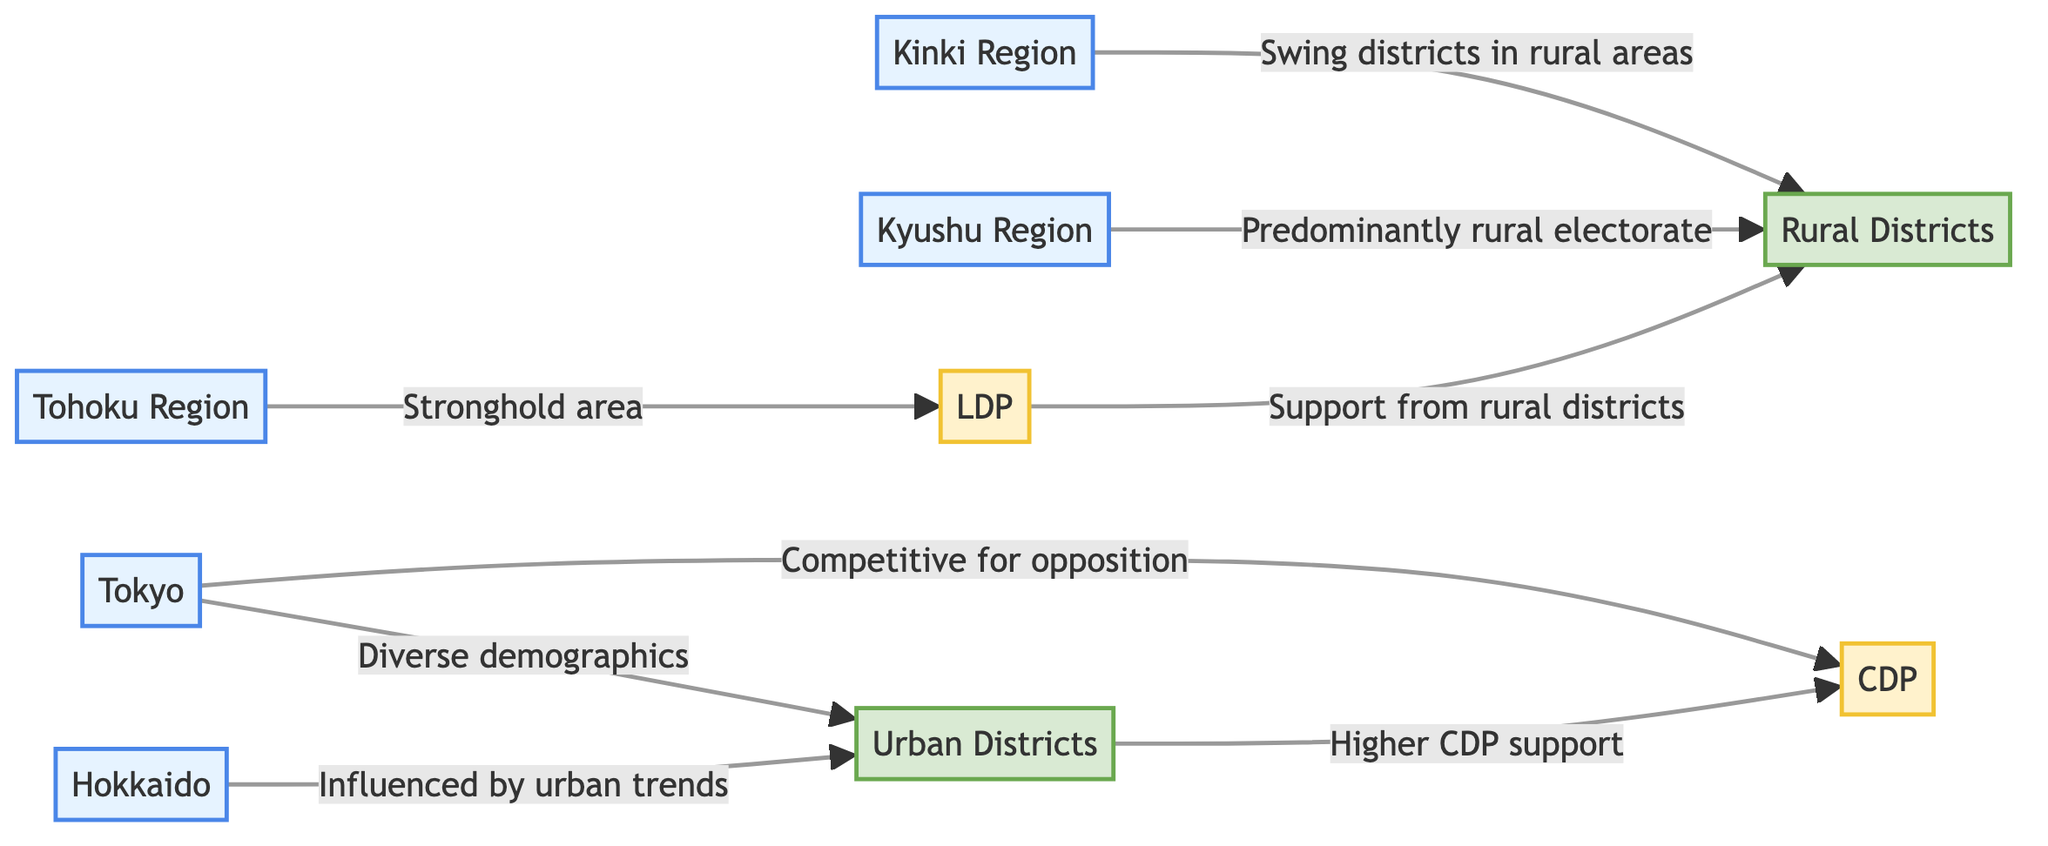What region in Japan is influenced by urban trends? The diagram connects Hokkaido to Urban Districts with the label "Influenced by urban trends," indicating that Hokkaido is affected by urban trends.
Answer: Hokkaido Which region shows a stronghold area for the LDP? The diagram connects the Tohoku Region with LDP, marked as a "Stronghold area," confirming that this region is known for its support for the Liberal Democratic Party.
Answer: Tohoku Region How many primary regions are illustrated in the diagram? By counting the regions shown in the diagram, we find five separate regions: Hokkaido, Tohoku Region, Tokyo, Kinki Region, and Kyushu Region.
Answer: 5 What party predominantly receives support from rural districts? The diagram shows a relationship where the LDP is linked with rural districts, indicating that the Liberal Democratic Party predominantly obtains support from these areas.
Answer: LDP Which districts have higher support for the CDP? According to the diagram, Urban Districts are connected to higher CDP support, indicating these districts favor the Constitutional Democratic Party.
Answer: Urban Districts Which regional area is described as having diverse demographics? The diagram connects Tokyo to Urban Districts, with the description "Diverse demographics," indicating that Tokyo's demographics are varied.
Answer: Tokyo In how many districts are swing districts mentioned? The diagram indicates that swing districts are present in the Kinki Region and rural areas, leading to a count of two distinct mentions of swing districts (Kinki Region and rural districts).
Answer: 2 What party is competitive in urban districts according to the diagram? The diagram indicates that the CDP is competitive in urban districts, highlighted with the label "Competitive for opposition," showing its position against the other parties.
Answer: CDP Which electoral area has a predominantly rural electorate? The connection from Kyushu Region to Rural Districts is marked as "Predominantly rural electorate," showing that this region has a largely rural voting base.
Answer: Kyushu Region 